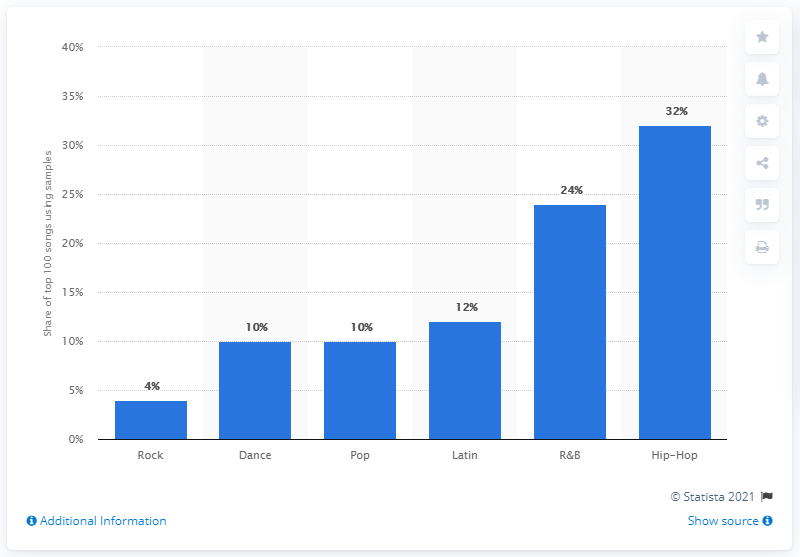Mention a couple of crucial points in this snapshot. The genre of rock was the least likely to include samples in its music. 